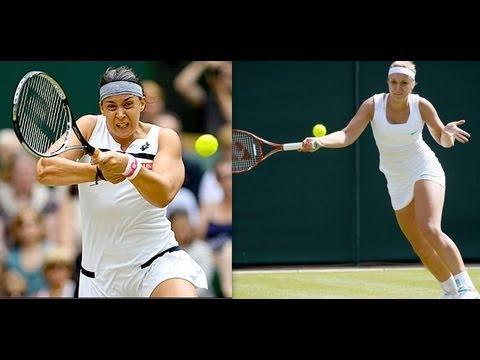How many people are shown?
Give a very brief answer. 2. How many tennis rackets are in the photo?
Give a very brief answer. 1. How many people are in the picture?
Give a very brief answer. 6. 